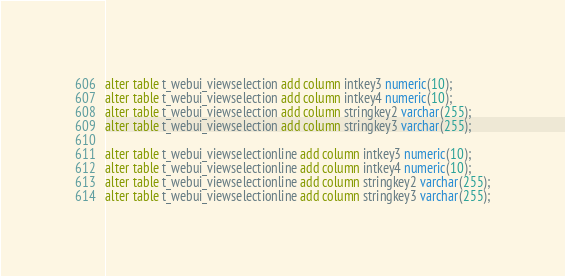Convert code to text. <code><loc_0><loc_0><loc_500><loc_500><_SQL_>alter table t_webui_viewselection add column intkey3 numeric(10);
alter table t_webui_viewselection add column intkey4 numeric(10);
alter table t_webui_viewselection add column stringkey2 varchar(255);
alter table t_webui_viewselection add column stringkey3 varchar(255);

alter table t_webui_viewselectionline add column intkey3 numeric(10);
alter table t_webui_viewselectionline add column intkey4 numeric(10);
alter table t_webui_viewselectionline add column stringkey2 varchar(255);
alter table t_webui_viewselectionline add column stringkey3 varchar(255);

</code> 